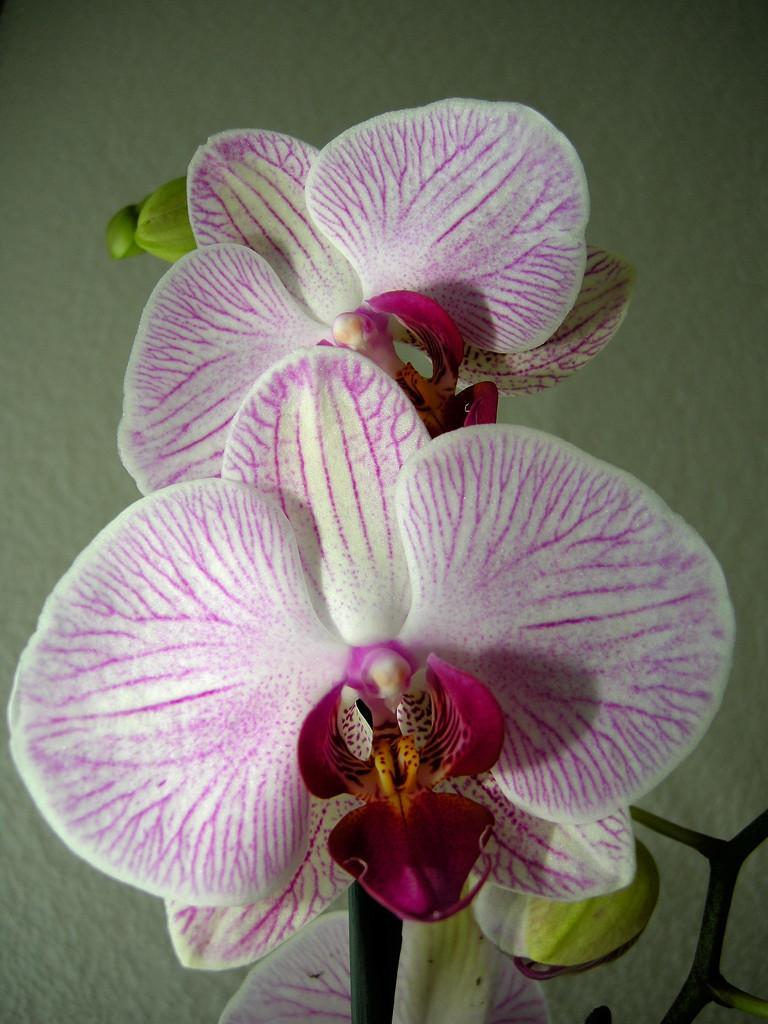In one or two sentences, can you explain what this image depicts? In this image we can see the flowers of a plant. Behind the flowers we can see a wall. 